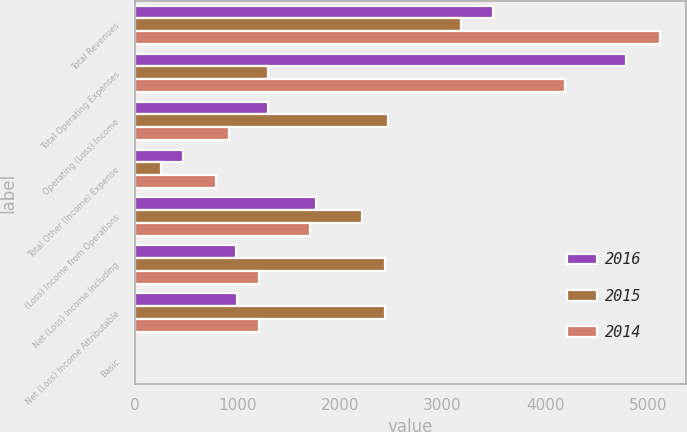Convert chart to OTSL. <chart><loc_0><loc_0><loc_500><loc_500><stacked_bar_chart><ecel><fcel>Total Revenues<fcel>Total Operating Expenses<fcel>Operating (Loss) Income<fcel>Total Other (Income) Expense<fcel>(Loss) Income from Operations<fcel>Net (Loss) Income Including<fcel>Net (Loss) Income Attributable<fcel>Basic<nl><fcel>2016<fcel>3491<fcel>4787<fcel>1296<fcel>476<fcel>1772<fcel>985<fcel>998<fcel>2.32<nl><fcel>2015<fcel>3183<fcel>1296<fcel>2472<fcel>253<fcel>2219<fcel>2441<fcel>2441<fcel>6.07<nl><fcel>2014<fcel>5115<fcel>4197<fcel>918<fcel>792<fcel>1710<fcel>1214<fcel>1214<fcel>3.36<nl></chart> 